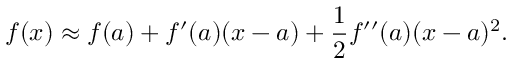<formula> <loc_0><loc_0><loc_500><loc_500>f ( x ) \approx f ( a ) + f ^ { \prime } ( a ) ( x - a ) + { \frac { 1 } { 2 } } f ^ { \prime \prime } ( a ) ( x - a ) ^ { 2 } .</formula> 